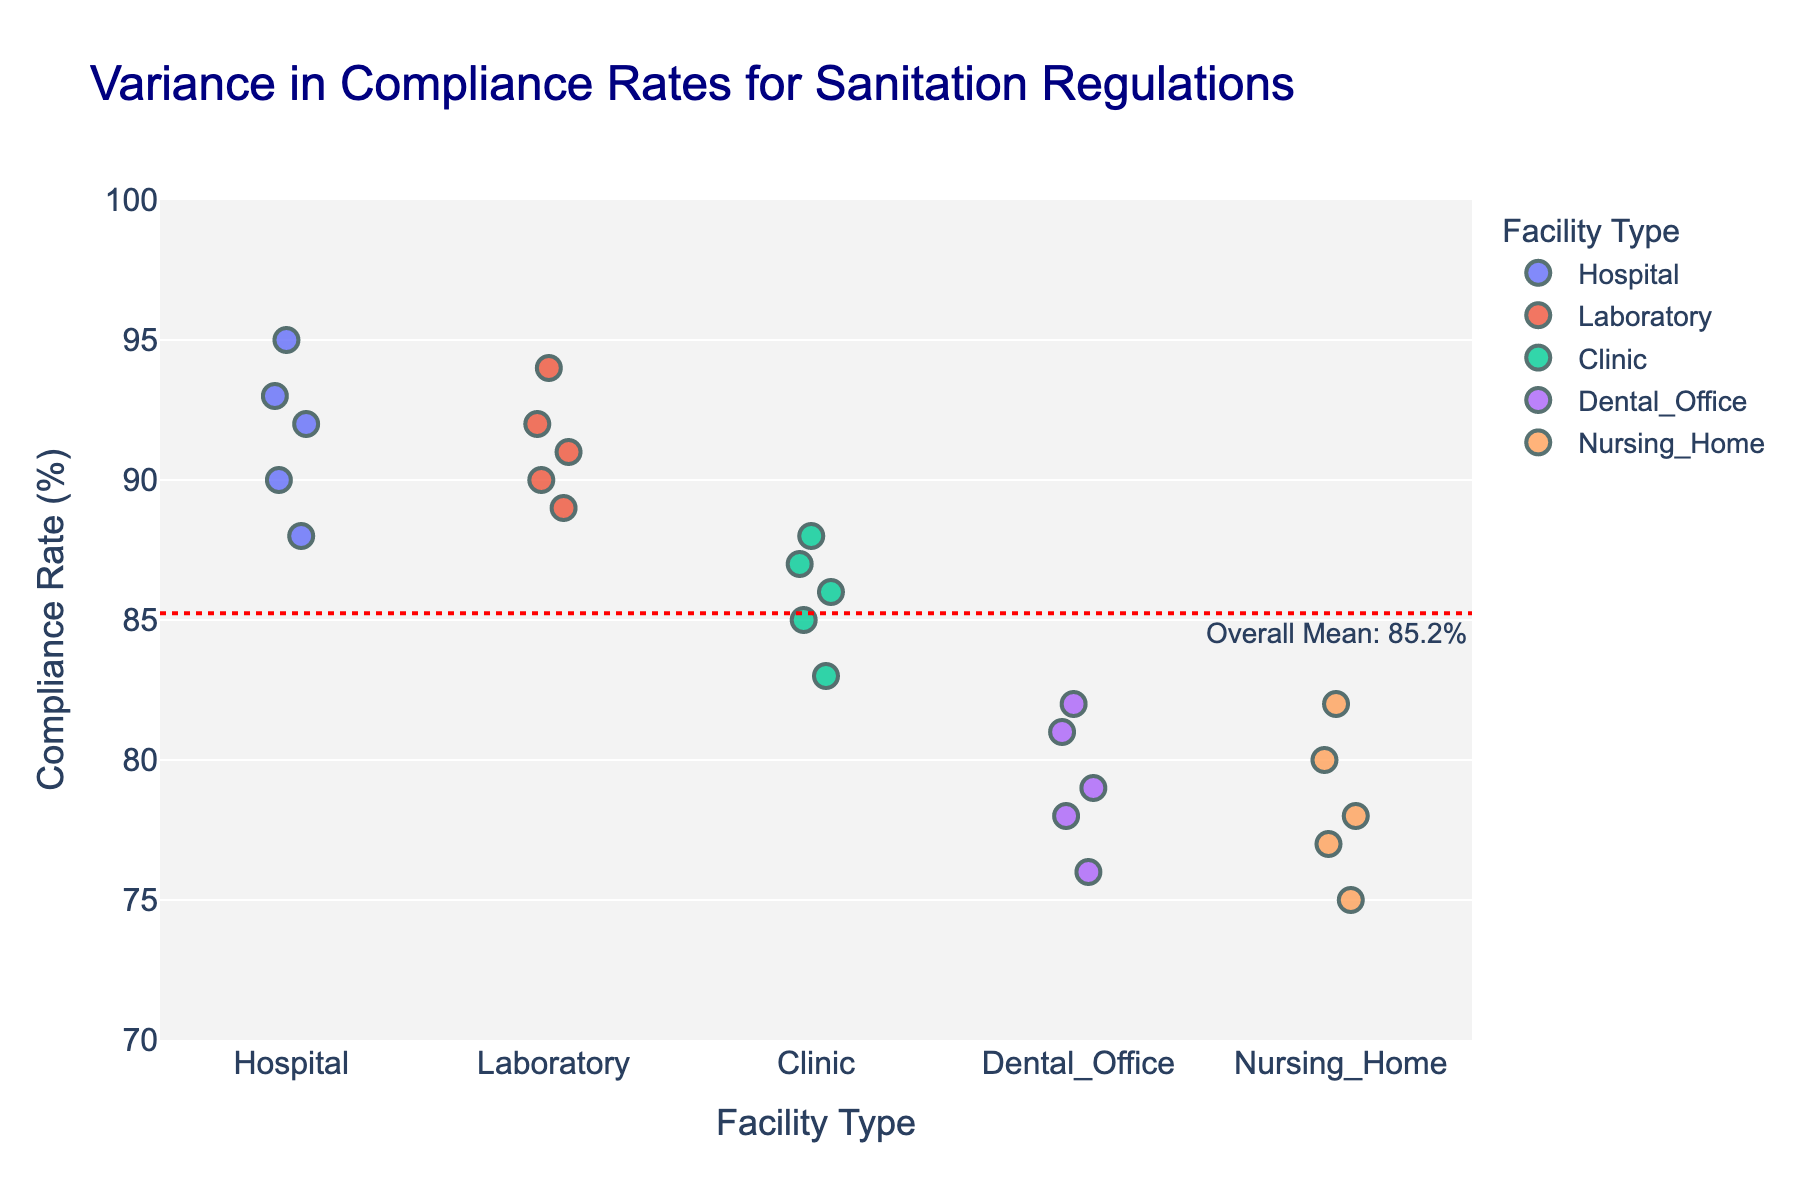What's the title of the figure? The title of the figure is displayed at the top or center of the plot, usually in a larger font size compared to other text elements. In this figure, the title is "Variance in Compliance Rates for Sanitation Regulations".
Answer: Variance in Compliance Rates for Sanitation Regulations What does the red dotted line represent on the plot? The red dotted line is an annotation on the plot, typically used to indicate a significant benchmark or reference value. In this plot, it represents the overall mean compliance rate, with an annotation text specifying the value.
Answer: Overall mean compliance rate Which facility type has the highest compliance rate? By examining the y-axis values and observing the individual data points, the facility type with the highest individual compliance rate can be determined. Here, it is the Hospital with a rate of 95%.
Answer: Hospital What is the range of compliance rates for Nursing Homes? The range is calculated by subtracting the smallest compliance rate from the largest compliance rate within the Nursing Home category. For Nursing Homes, the rates range from 75% to 82%. The calculation is 82 - 75 = 7.
Answer: 75% to 82% Which facility type shows the greatest variance in compliance rates? Variance can be visually assessed by observing the spread of the data points along the y-axis for each facility type. The Nursing Home category has the widest spread of compliance rates, indicating the greatest variance.
Answer: Nursing Home How many data points are there for each facility type? Data points can be counted by examining the number of points displayed for each category on the x-axis. Each facility type in the plot (Hospital, Nursing Home, Clinic, Dental Office, Laboratory) has exactly 5 data points.
Answer: 5 What is the mean compliance rate for Dental Offices? To find the mean, sum the compliance rates for the Dental Office category and divide by the number of data points. The rates are 79, 82, 76, 81, 78. The sum is 396, and the mean is 396 / 5 = 79.2%.
Answer: 79.2% Which facility type has data points closest to the overall mean compliance rate? By comparing the data points of each facility type to the red dotted line, which denotes the overall mean, the point closest to the line can be identified. The Laboratory has compliance rates close to the overall mean.
Answer: Laboratory What is the difference between the highest and lowest compliance rate for Clinics? The difference is found by subtracting the smallest compliance rate from the largest within the Clinic category. The rates are 83, 85, 86, 87, 88; thus, the difference is 88 - 83 = 5.
Answer: 5 Which facility types have at least one compliance rate below 80%? By inspecting the y-axis values for each category, we see that Nursing Home and Dental Office have data points that fall below 80% compliance.
Answer: Nursing Home, Dental Office 